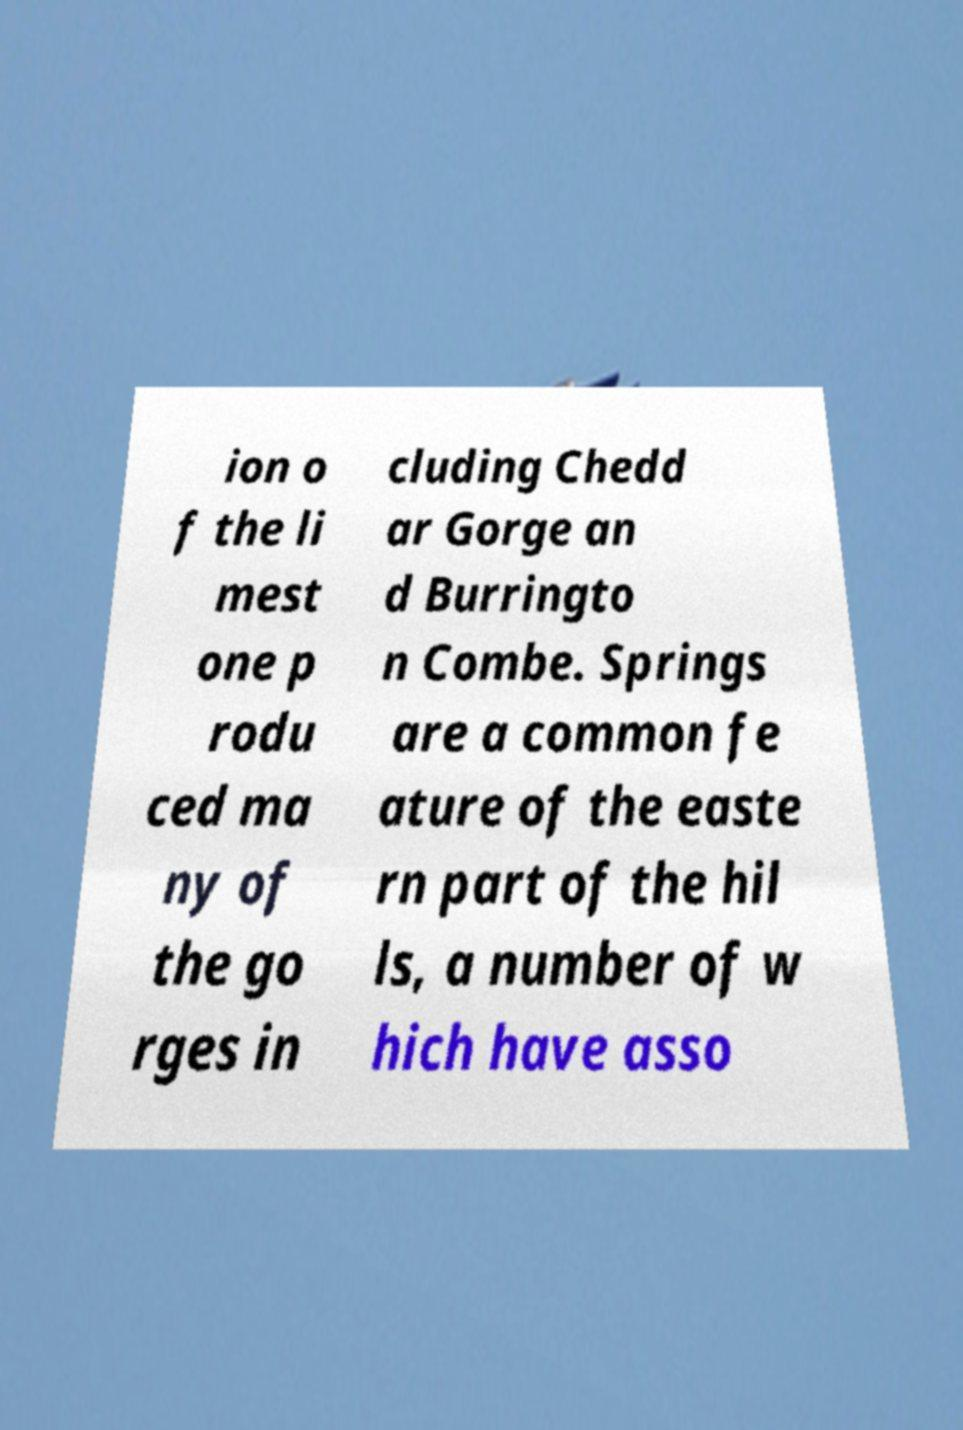Could you extract and type out the text from this image? ion o f the li mest one p rodu ced ma ny of the go rges in cluding Chedd ar Gorge an d Burringto n Combe. Springs are a common fe ature of the easte rn part of the hil ls, a number of w hich have asso 